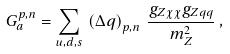<formula> <loc_0><loc_0><loc_500><loc_500>G _ { a } ^ { p , n } = \sum _ { u , d , s } \, \left ( \Delta q \right ) _ { p , n } \, \frac { g _ { Z \chi \chi } g _ { Z q q } } { m _ { Z } ^ { 2 } } \, ,</formula> 